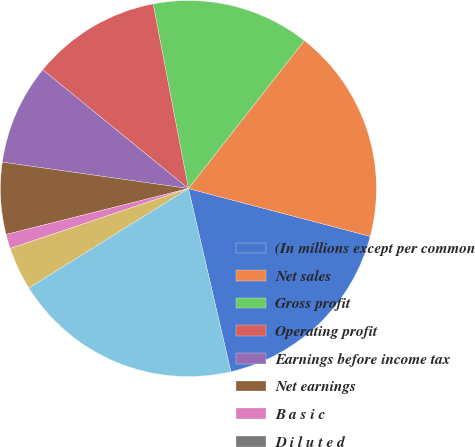Convert chart. <chart><loc_0><loc_0><loc_500><loc_500><pie_chart><fcel>(In millions except per common<fcel>Net sales<fcel>Gross profit<fcel>Operating profit<fcel>Earnings before income tax<fcel>Net earnings<fcel>B a s i c<fcel>D i l u t e d<fcel>Cash and cash equivalents<fcel>Total assets<nl><fcel>17.28%<fcel>18.52%<fcel>13.58%<fcel>11.11%<fcel>8.64%<fcel>6.17%<fcel>1.24%<fcel>0.0%<fcel>3.71%<fcel>19.75%<nl></chart> 